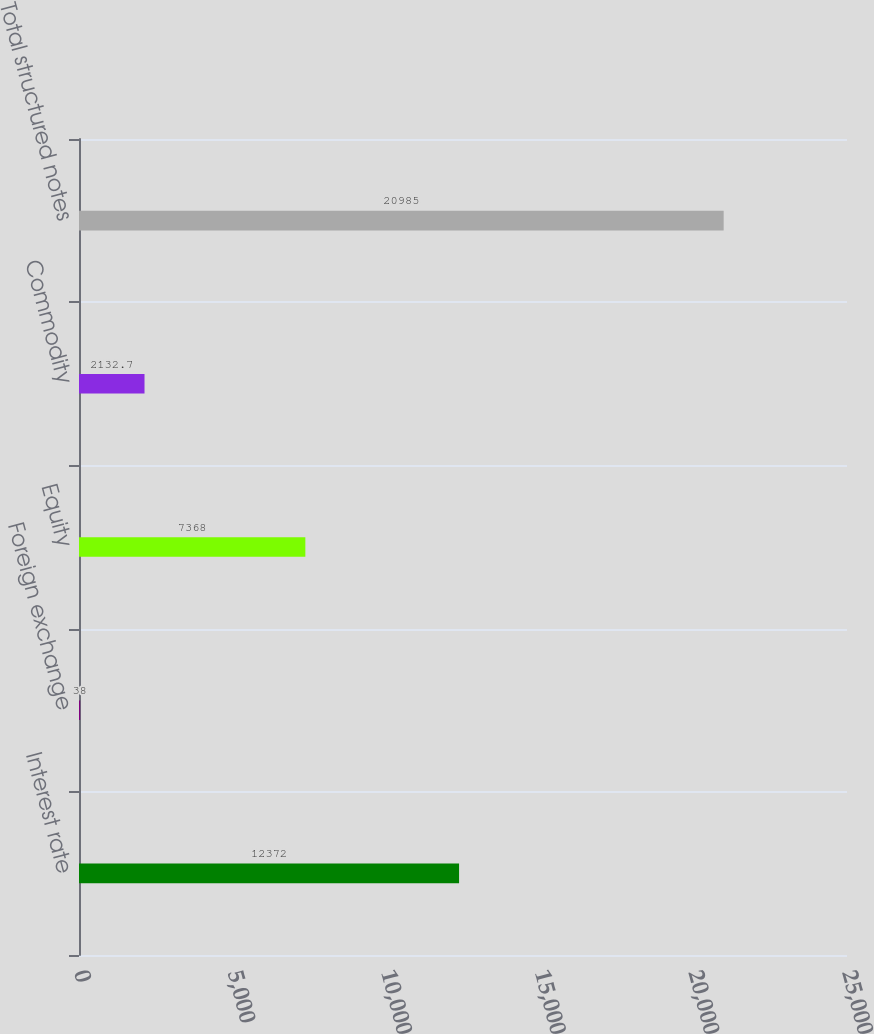Convert chart to OTSL. <chart><loc_0><loc_0><loc_500><loc_500><bar_chart><fcel>Interest rate<fcel>Foreign exchange<fcel>Equity<fcel>Commodity<fcel>Total structured notes<nl><fcel>12372<fcel>38<fcel>7368<fcel>2132.7<fcel>20985<nl></chart> 